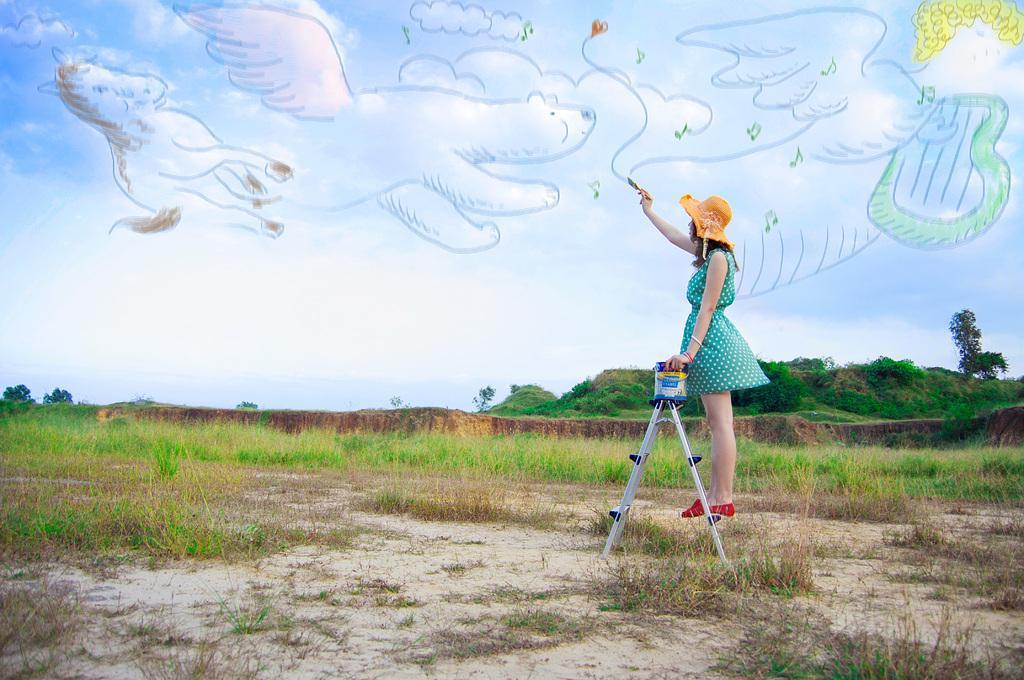Describe this image in one or two sentences. This looks like an edited image. Here is the woman standing on the ladder and holding a paint brush. She wore a hat, dress and shoes. Here is the grass. This looks like a drawing in the sky. I can see the trees. 